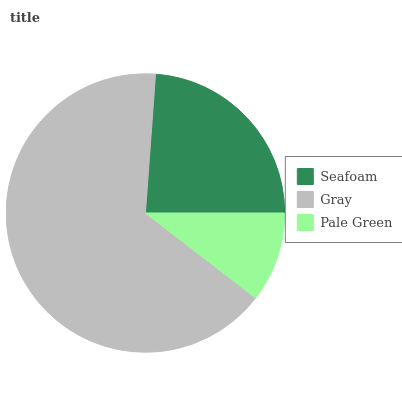Is Pale Green the minimum?
Answer yes or no. Yes. Is Gray the maximum?
Answer yes or no. Yes. Is Gray the minimum?
Answer yes or no. No. Is Pale Green the maximum?
Answer yes or no. No. Is Gray greater than Pale Green?
Answer yes or no. Yes. Is Pale Green less than Gray?
Answer yes or no. Yes. Is Pale Green greater than Gray?
Answer yes or no. No. Is Gray less than Pale Green?
Answer yes or no. No. Is Seafoam the high median?
Answer yes or no. Yes. Is Seafoam the low median?
Answer yes or no. Yes. Is Pale Green the high median?
Answer yes or no. No. Is Pale Green the low median?
Answer yes or no. No. 